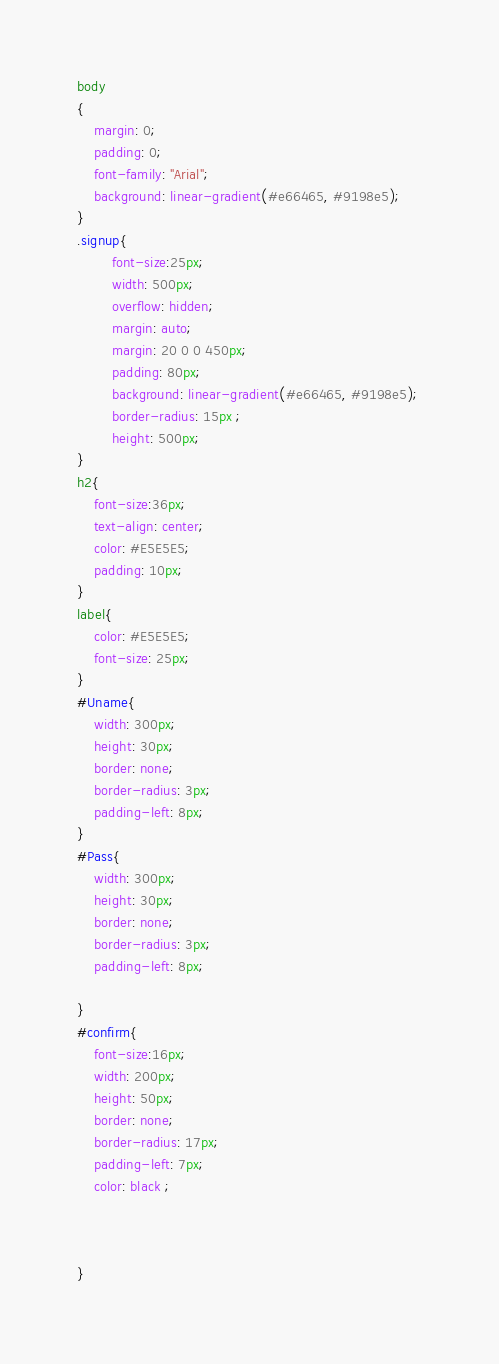Convert code to text. <code><loc_0><loc_0><loc_500><loc_500><_CSS_>body  
{  
    margin: 0;  
    padding: 0;  
    font-family: "Arial";
    background: linear-gradient(#e66465, #9198e5); 
}  
.signup{  
        font-size:25px;
        width: 500px;  
        overflow: hidden;  
        margin: auto;  
        margin: 20 0 0 450px;  
        padding: 80px;  
        background: linear-gradient(#e66465, #9198e5); 
        border-radius: 15px ;  
        height: 500px;
}  
h2{  
    font-size:36px;
    text-align: center;  
    color: #E5E5E5;  
    padding: 10px;  
}  
label{  
    color: #E5E5E5;  
    font-size: 25px;  
}  
#Uname{  
    width: 300px;  
    height: 30px;  
    border: none;  
    border-radius: 3px;  
    padding-left: 8px;  
}  
#Pass{  
    width: 300px;  
    height: 30px;  
    border: none;  
    border-radius: 3px;  
    padding-left: 8px;  
      
}  
#confirm{  
    font-size:16px;
    width: 200px;  
    height: 50px;  
    border: none;  
    border-radius: 17px;  
    padding-left: 7px;  
    color: black ; 

  
  
}  
</code> 